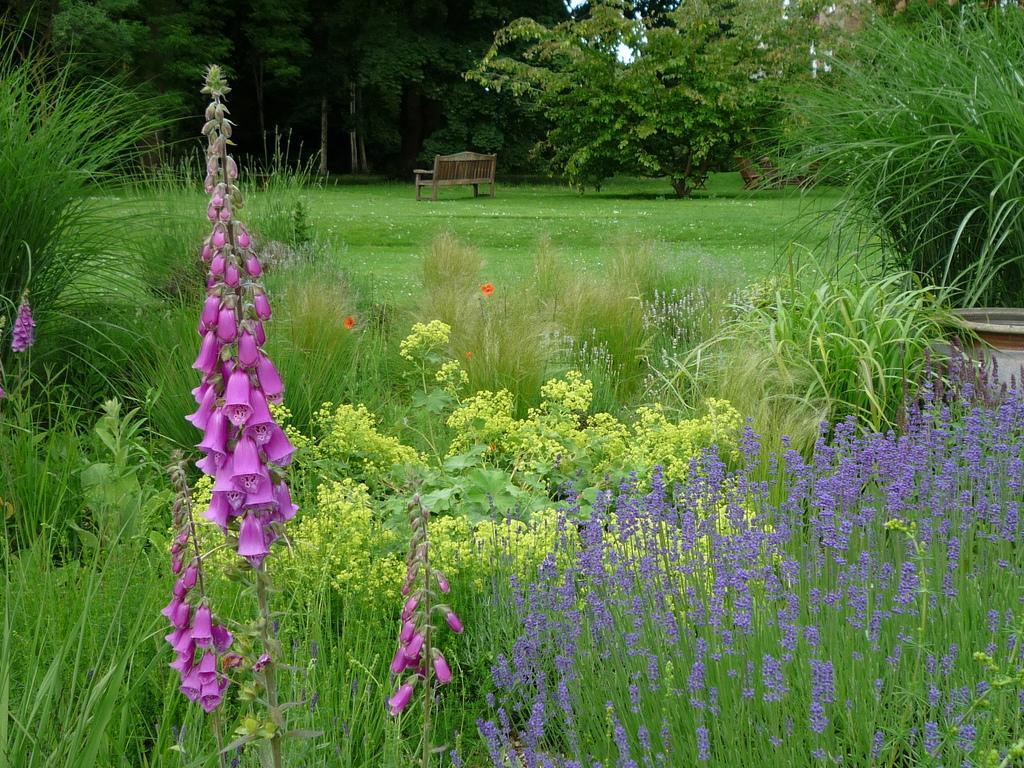How would you summarize this image in a sentence or two? In this image I can see few plants which are green in color and few flowers which are pink, purple and orange in color. In the background I can see few trees which are green in color, a brown colored bench and the sky. 